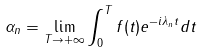Convert formula to latex. <formula><loc_0><loc_0><loc_500><loc_500>\alpha _ { n } = \lim _ { T \rightarrow + \infty } \int _ { 0 } ^ { T } f ( t ) e ^ { - i \lambda _ { n } t } d t</formula> 